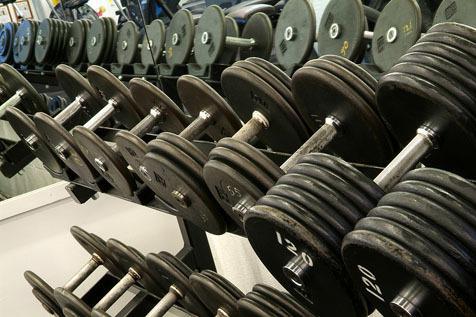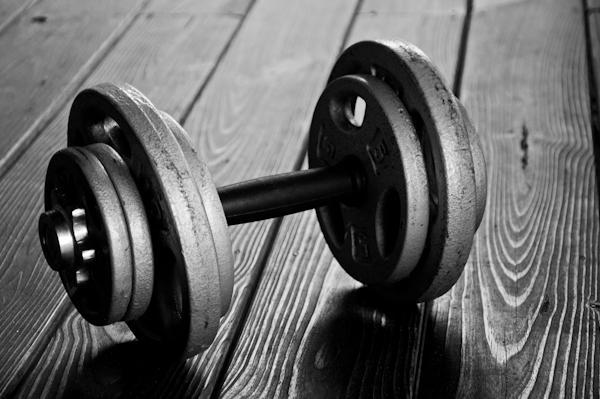The first image is the image on the left, the second image is the image on the right. Analyze the images presented: Is the assertion "The round weights are sitting on the floor in one of the images." valid? Answer yes or no. Yes. The first image is the image on the left, the second image is the image on the right. Evaluate the accuracy of this statement regarding the images: "The dumbbells closest to the camera in one image have beveled edges instead of round edges.". Is it true? Answer yes or no. No. 